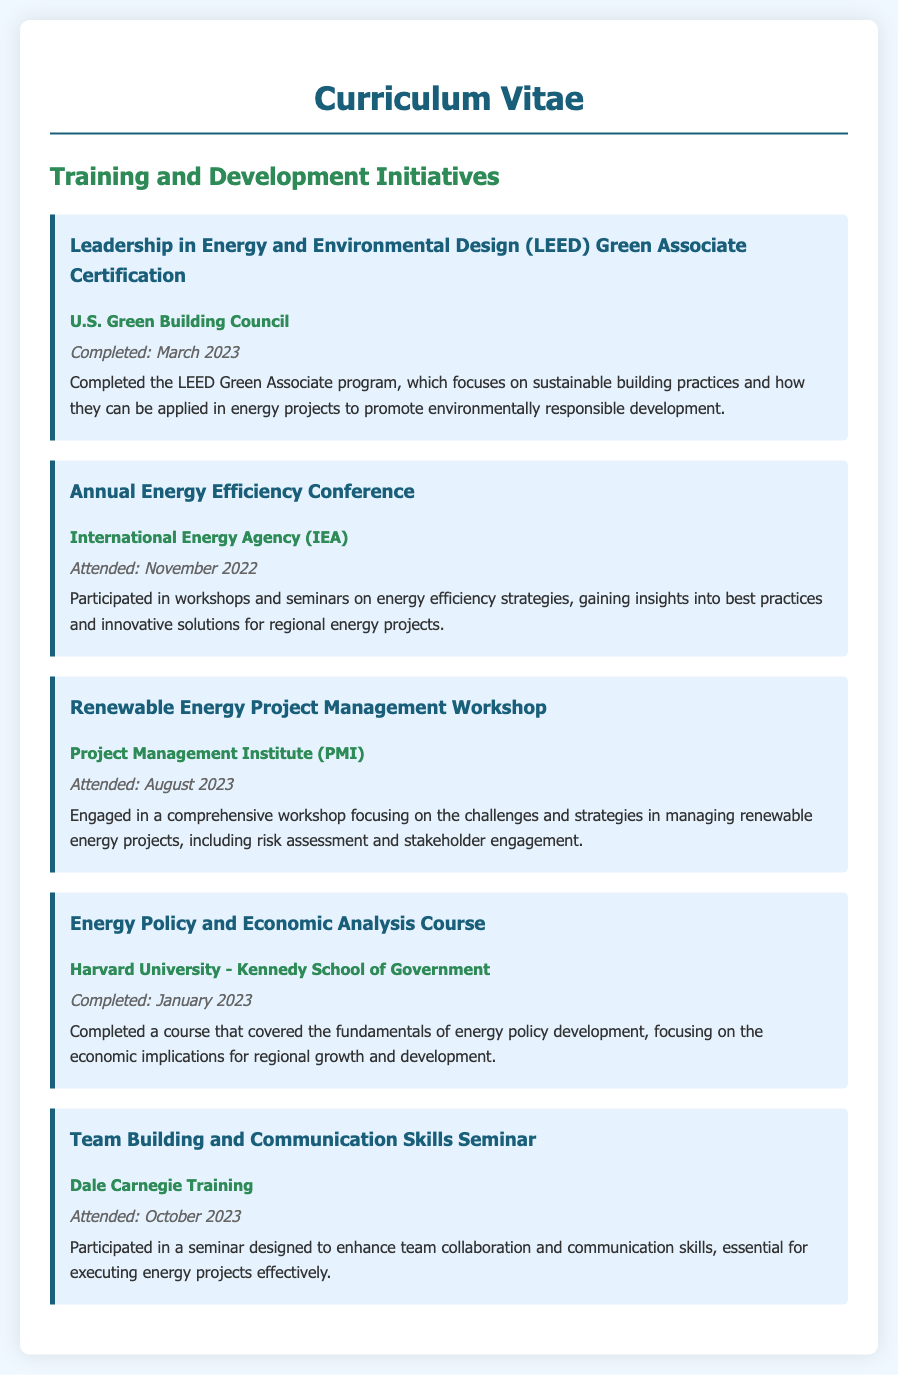what is the title of the first certification completed? The title of the first certification completed is listed under the first initiative in the document.
Answer: Leadership in Energy and Environmental Design (LEED) Green Associate Certification who provided the Team Building and Communication Skills Seminar? The provider of the seminar is mentioned in the initiative's description.
Answer: Dale Carnegie Training when was the Renewable Energy Project Management Workshop attended? The date for the workshop is specified in the initiative section referring to this training.
Answer: August 2023 what is the focus of the Energy Policy and Economic Analysis Course? The focus of the course is explained in the summary of the initiative.
Answer: Fundamentals of energy policy development how many training initiatives are listed in the document? The total number of training initiatives can be counted based on their presentation in the document.
Answer: Five which organization offered the Annual Energy Efficiency Conference? The provider of the conference is indicated in its corresponding initiative.
Answer: International Energy Agency (IEA) in what month was the LEED certification completed? The month of completion for the LEED certification is specified in the date section of the initiative.
Answer: March what type of skills were enhanced in the Team Building and Communication Skills Seminar? The skills enhanced are specifically mentioned in the initiative's description.
Answer: Team collaboration and communication skills 